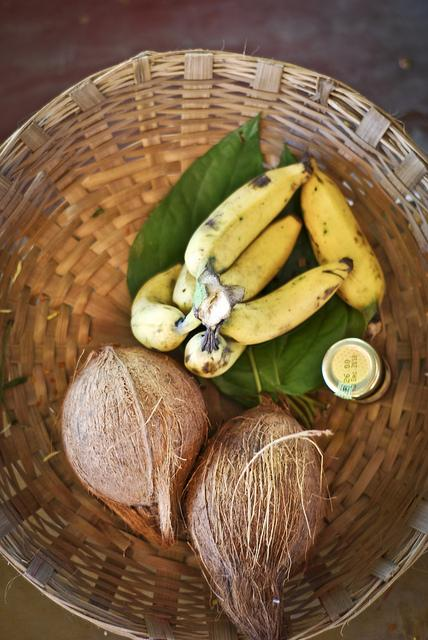What is the best climate for these fruits to grow in?

Choices:
A) dry
B) arid
C) polar
D) tropical tropical 